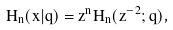Convert formula to latex. <formula><loc_0><loc_0><loc_500><loc_500>H _ { n } ( x | q ) = z ^ { n } H _ { n } ( z ^ { - 2 } ; q ) ,</formula> 